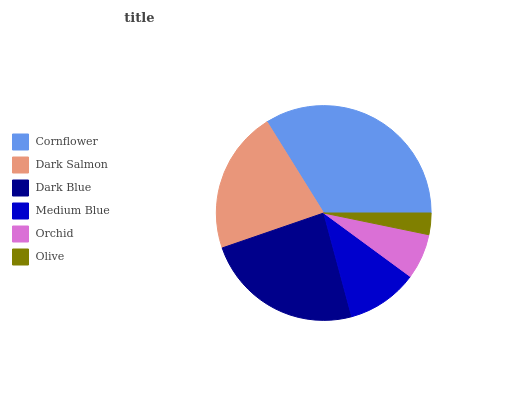Is Olive the minimum?
Answer yes or no. Yes. Is Cornflower the maximum?
Answer yes or no. Yes. Is Dark Salmon the minimum?
Answer yes or no. No. Is Dark Salmon the maximum?
Answer yes or no. No. Is Cornflower greater than Dark Salmon?
Answer yes or no. Yes. Is Dark Salmon less than Cornflower?
Answer yes or no. Yes. Is Dark Salmon greater than Cornflower?
Answer yes or no. No. Is Cornflower less than Dark Salmon?
Answer yes or no. No. Is Dark Salmon the high median?
Answer yes or no. Yes. Is Medium Blue the low median?
Answer yes or no. Yes. Is Olive the high median?
Answer yes or no. No. Is Cornflower the low median?
Answer yes or no. No. 